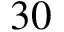<formula> <loc_0><loc_0><loc_500><loc_500>3 0</formula> 